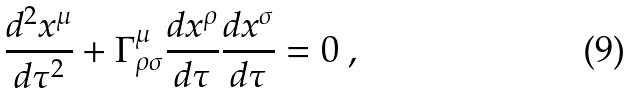Convert formula to latex. <formula><loc_0><loc_0><loc_500><loc_500>\frac { d ^ { 2 } x ^ { \mu } } { d \tau ^ { 2 } } + \Gamma ^ { \mu } _ { \rho \sigma } \frac { d x ^ { \rho } } { d \tau } \frac { d x ^ { \sigma } } { d \tau } = 0 \ ,</formula> 